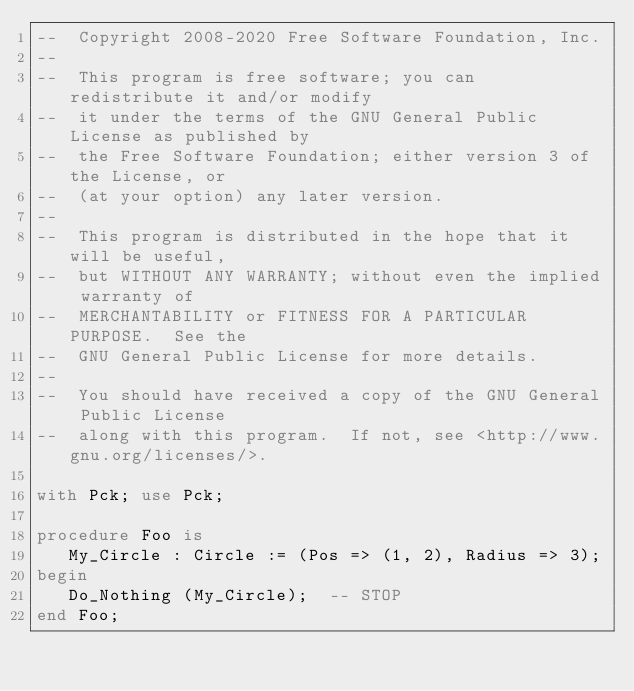Convert code to text. <code><loc_0><loc_0><loc_500><loc_500><_Ada_>--  Copyright 2008-2020 Free Software Foundation, Inc.
--
--  This program is free software; you can redistribute it and/or modify
--  it under the terms of the GNU General Public License as published by
--  the Free Software Foundation; either version 3 of the License, or
--  (at your option) any later version.
--
--  This program is distributed in the hope that it will be useful,
--  but WITHOUT ANY WARRANTY; without even the implied warranty of
--  MERCHANTABILITY or FITNESS FOR A PARTICULAR PURPOSE.  See the
--  GNU General Public License for more details.
--
--  You should have received a copy of the GNU General Public License
--  along with this program.  If not, see <http://www.gnu.org/licenses/>.

with Pck; use Pck;

procedure Foo is
   My_Circle : Circle := (Pos => (1, 2), Radius => 3);
begin
   Do_Nothing (My_Circle);  -- STOP
end Foo;
</code> 